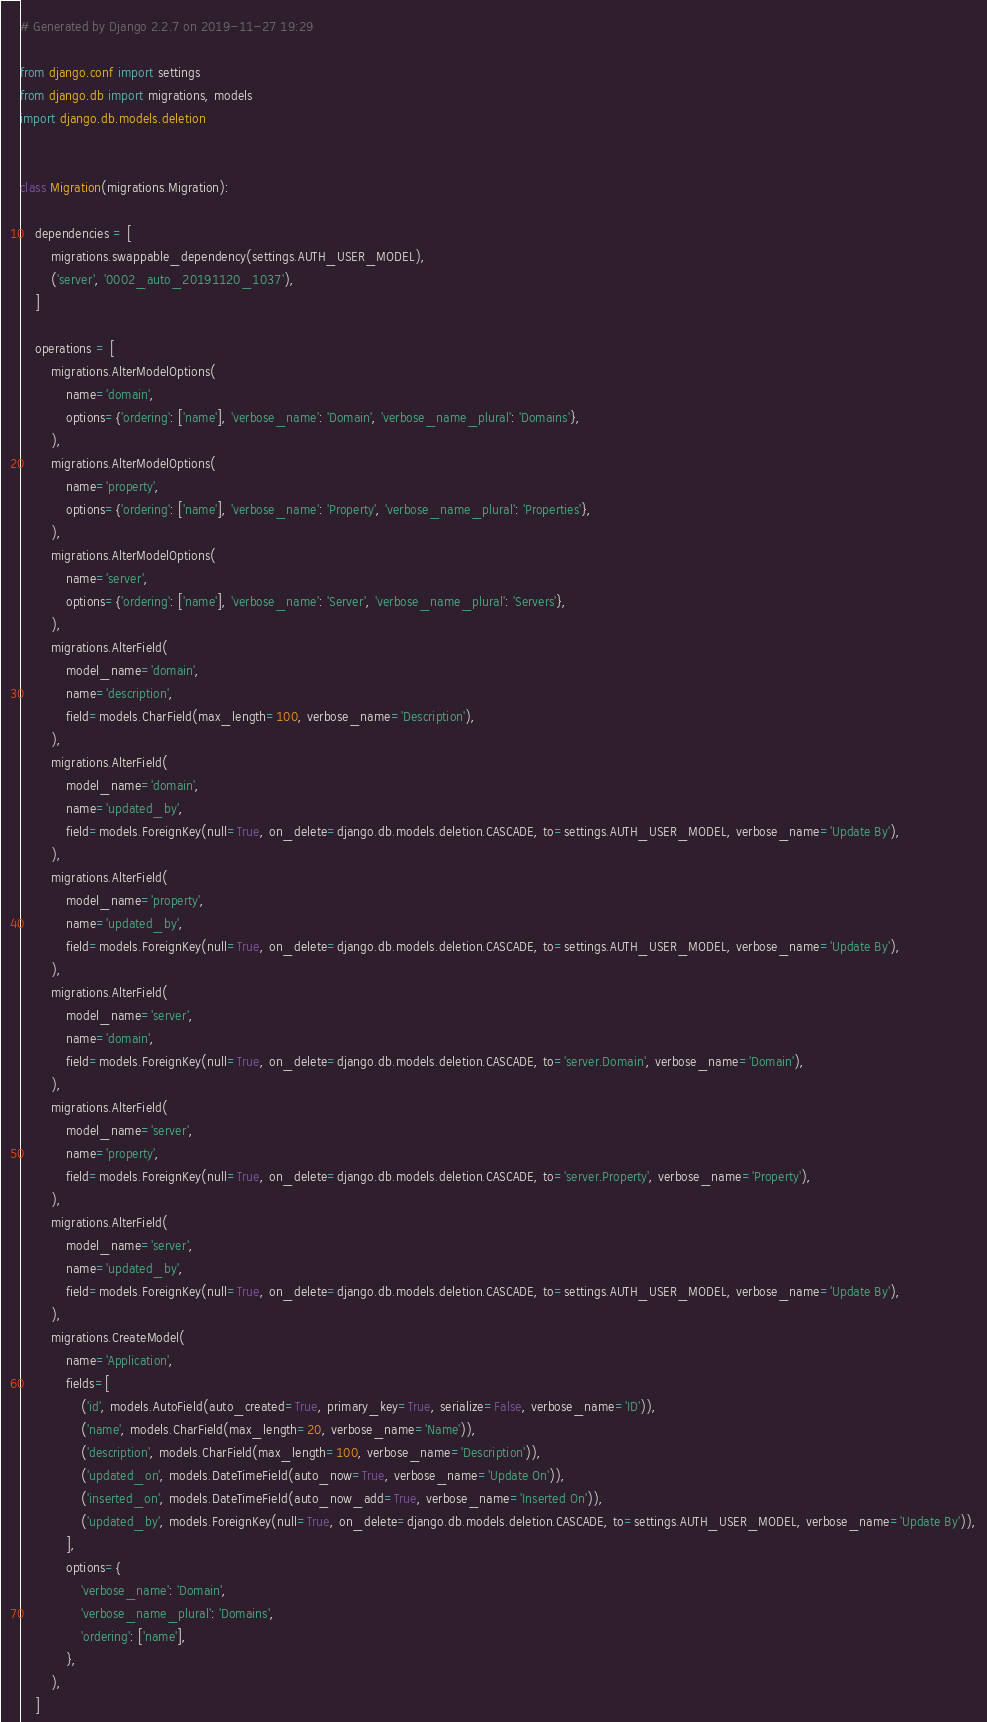<code> <loc_0><loc_0><loc_500><loc_500><_Python_># Generated by Django 2.2.7 on 2019-11-27 19:29

from django.conf import settings
from django.db import migrations, models
import django.db.models.deletion


class Migration(migrations.Migration):

    dependencies = [
        migrations.swappable_dependency(settings.AUTH_USER_MODEL),
        ('server', '0002_auto_20191120_1037'),
    ]

    operations = [
        migrations.AlterModelOptions(
            name='domain',
            options={'ordering': ['name'], 'verbose_name': 'Domain', 'verbose_name_plural': 'Domains'},
        ),
        migrations.AlterModelOptions(
            name='property',
            options={'ordering': ['name'], 'verbose_name': 'Property', 'verbose_name_plural': 'Properties'},
        ),
        migrations.AlterModelOptions(
            name='server',
            options={'ordering': ['name'], 'verbose_name': 'Server', 'verbose_name_plural': 'Servers'},
        ),
        migrations.AlterField(
            model_name='domain',
            name='description',
            field=models.CharField(max_length=100, verbose_name='Description'),
        ),
        migrations.AlterField(
            model_name='domain',
            name='updated_by',
            field=models.ForeignKey(null=True, on_delete=django.db.models.deletion.CASCADE, to=settings.AUTH_USER_MODEL, verbose_name='Update By'),
        ),
        migrations.AlterField(
            model_name='property',
            name='updated_by',
            field=models.ForeignKey(null=True, on_delete=django.db.models.deletion.CASCADE, to=settings.AUTH_USER_MODEL, verbose_name='Update By'),
        ),
        migrations.AlterField(
            model_name='server',
            name='domain',
            field=models.ForeignKey(null=True, on_delete=django.db.models.deletion.CASCADE, to='server.Domain', verbose_name='Domain'),
        ),
        migrations.AlterField(
            model_name='server',
            name='property',
            field=models.ForeignKey(null=True, on_delete=django.db.models.deletion.CASCADE, to='server.Property', verbose_name='Property'),
        ),
        migrations.AlterField(
            model_name='server',
            name='updated_by',
            field=models.ForeignKey(null=True, on_delete=django.db.models.deletion.CASCADE, to=settings.AUTH_USER_MODEL, verbose_name='Update By'),
        ),
        migrations.CreateModel(
            name='Application',
            fields=[
                ('id', models.AutoField(auto_created=True, primary_key=True, serialize=False, verbose_name='ID')),
                ('name', models.CharField(max_length=20, verbose_name='Name')),
                ('description', models.CharField(max_length=100, verbose_name='Description')),
                ('updated_on', models.DateTimeField(auto_now=True, verbose_name='Update On')),
                ('inserted_on', models.DateTimeField(auto_now_add=True, verbose_name='Inserted On')),
                ('updated_by', models.ForeignKey(null=True, on_delete=django.db.models.deletion.CASCADE, to=settings.AUTH_USER_MODEL, verbose_name='Update By')),
            ],
            options={
                'verbose_name': 'Domain',
                'verbose_name_plural': 'Domains',
                'ordering': ['name'],
            },
        ),
    ]
</code> 